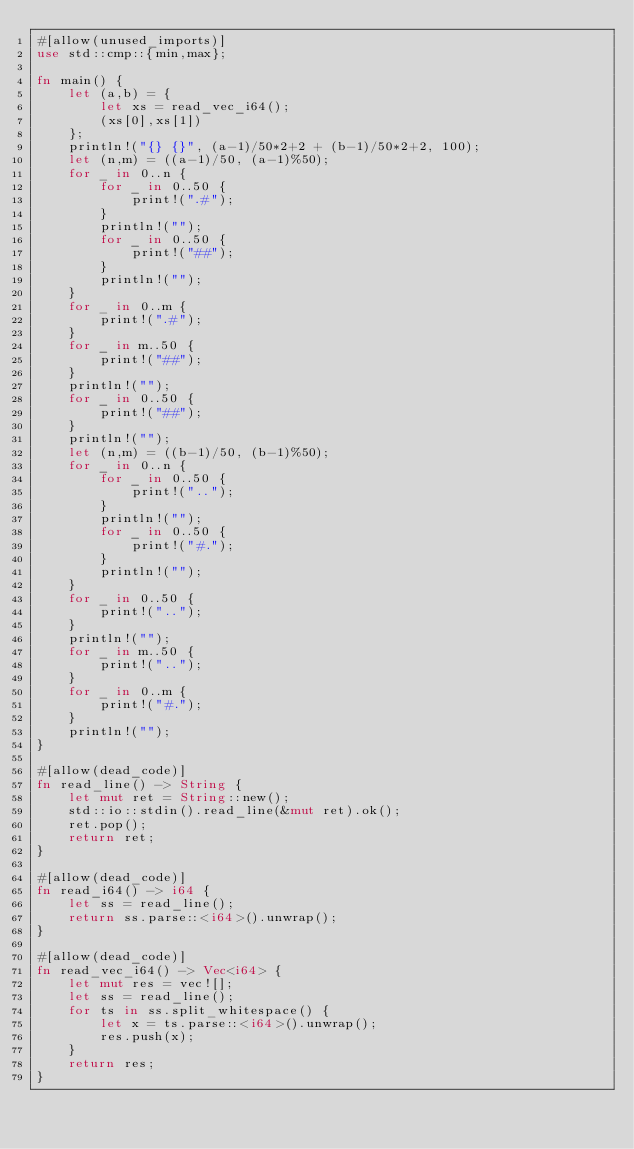Convert code to text. <code><loc_0><loc_0><loc_500><loc_500><_Rust_>#[allow(unused_imports)]
use std::cmp::{min,max};

fn main() {
    let (a,b) = {
        let xs = read_vec_i64();
        (xs[0],xs[1])
    };
    println!("{} {}", (a-1)/50*2+2 + (b-1)/50*2+2, 100);
    let (n,m) = ((a-1)/50, (a-1)%50);
    for _ in 0..n {
        for _ in 0..50 {
            print!(".#");
        }
        println!("");
        for _ in 0..50 {
            print!("##");
        }
        println!("");
    }
    for _ in 0..m {
        print!(".#");
    }
    for _ in m..50 {
        print!("##");
    }
    println!("");
    for _ in 0..50 {
        print!("##");
    }
    println!("");
    let (n,m) = ((b-1)/50, (b-1)%50);
    for _ in 0..n {
        for _ in 0..50 {
            print!("..");
        }
        println!("");
        for _ in 0..50 {
            print!("#.");
        }
        println!("");
    }
    for _ in 0..50 {
        print!("..");
    }
    println!("");
    for _ in m..50 {
        print!("..");
    }
    for _ in 0..m {
        print!("#.");
    }
    println!("");
}

#[allow(dead_code)]
fn read_line() -> String {
    let mut ret = String::new();
    std::io::stdin().read_line(&mut ret).ok();
    ret.pop();
    return ret;
}

#[allow(dead_code)]
fn read_i64() -> i64 {
    let ss = read_line();
    return ss.parse::<i64>().unwrap();
}

#[allow(dead_code)]
fn read_vec_i64() -> Vec<i64> {
    let mut res = vec![];
    let ss = read_line();
    for ts in ss.split_whitespace() {
        let x = ts.parse::<i64>().unwrap();
        res.push(x);
    }
    return res;
}
</code> 